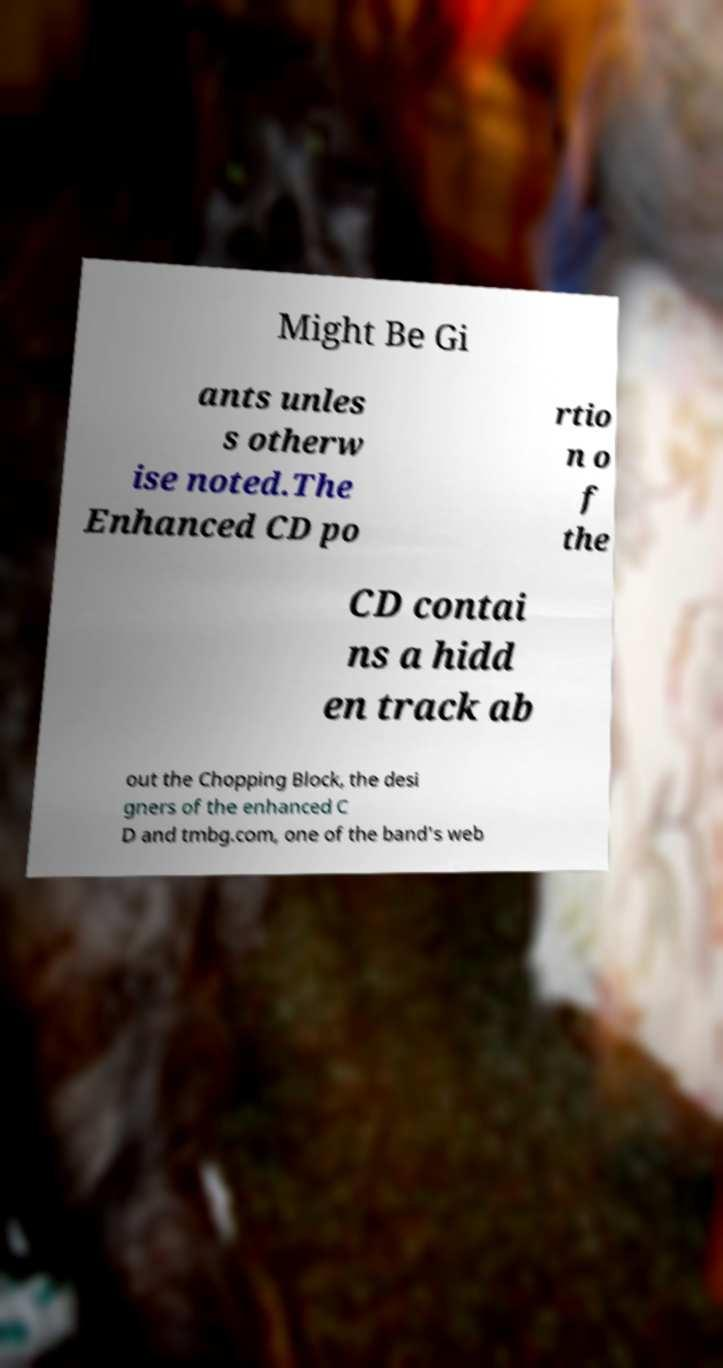Please read and relay the text visible in this image. What does it say? Might Be Gi ants unles s otherw ise noted.The Enhanced CD po rtio n o f the CD contai ns a hidd en track ab out the Chopping Block, the desi gners of the enhanced C D and tmbg.com, one of the band's web 